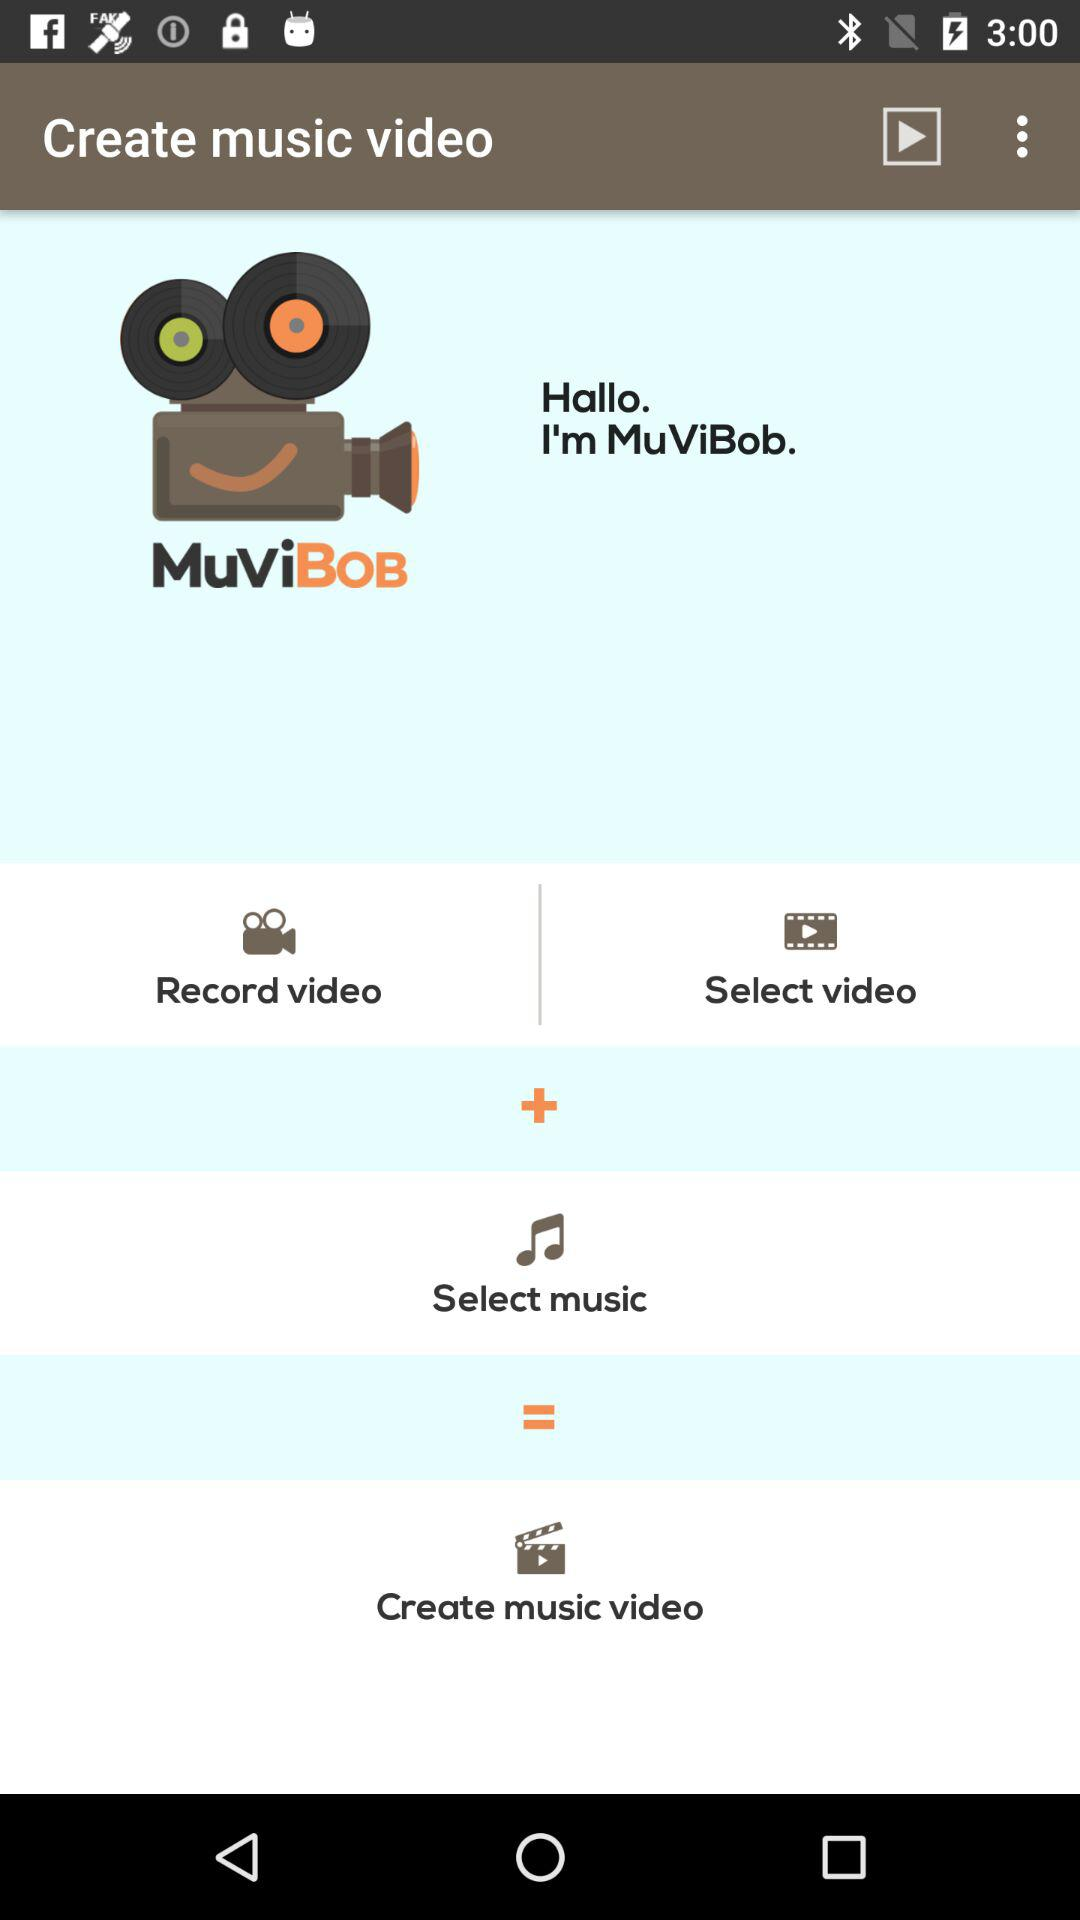What is the name of the application? The name of the application is "MuViBob". 